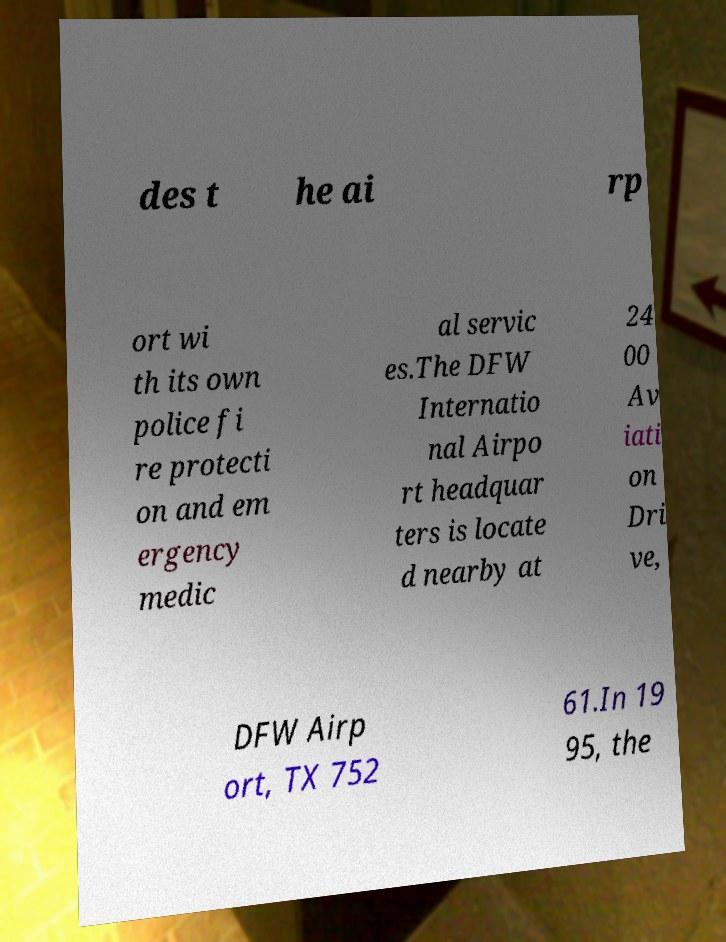I need the written content from this picture converted into text. Can you do that? des t he ai rp ort wi th its own police fi re protecti on and em ergency medic al servic es.The DFW Internatio nal Airpo rt headquar ters is locate d nearby at 24 00 Av iati on Dri ve, DFW Airp ort, TX 752 61.In 19 95, the 